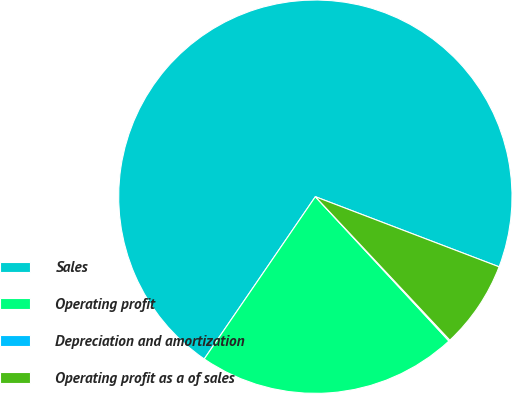Convert chart. <chart><loc_0><loc_0><loc_500><loc_500><pie_chart><fcel>Sales<fcel>Operating profit<fcel>Depreciation and amortization<fcel>Operating profit as a of sales<nl><fcel>71.24%<fcel>21.44%<fcel>0.1%<fcel>7.21%<nl></chart> 